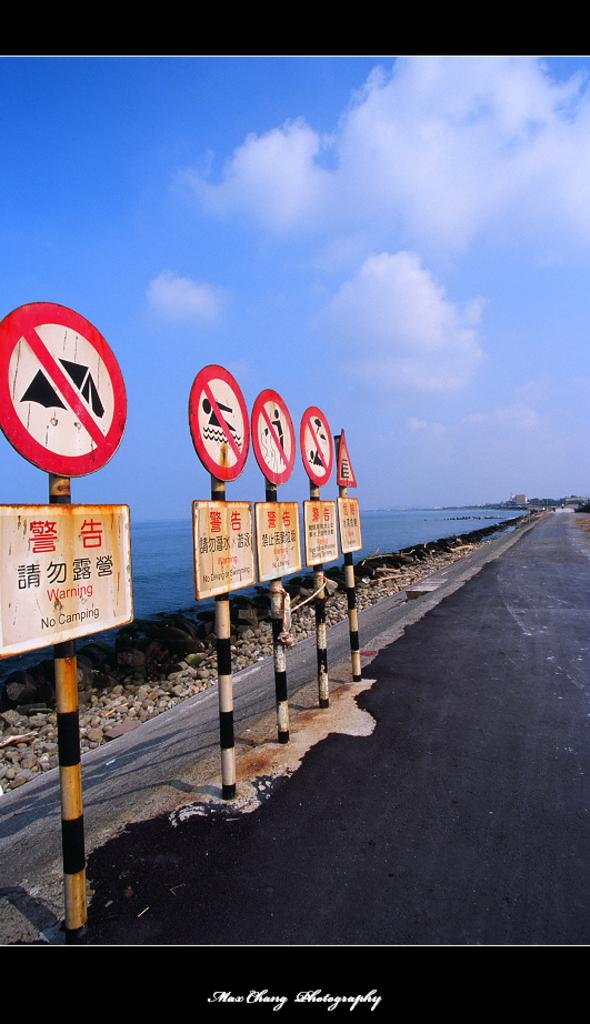<image>
Write a terse but informative summary of the picture. Signs on the side of a road in a foreign language. 